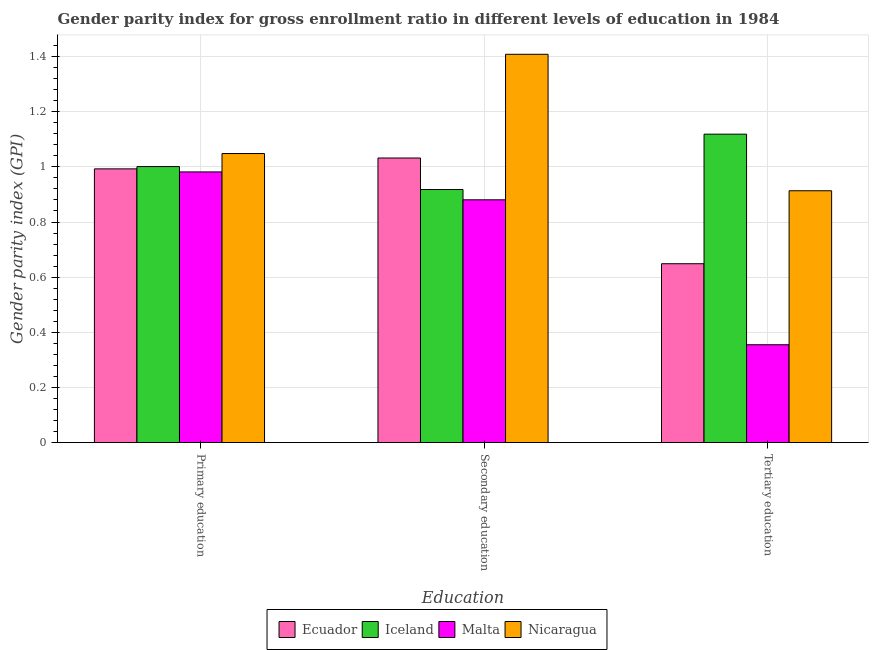How many different coloured bars are there?
Offer a very short reply. 4. How many groups of bars are there?
Your answer should be very brief. 3. What is the label of the 3rd group of bars from the left?
Your answer should be compact. Tertiary education. What is the gender parity index in primary education in Ecuador?
Offer a very short reply. 0.99. Across all countries, what is the maximum gender parity index in primary education?
Make the answer very short. 1.05. Across all countries, what is the minimum gender parity index in tertiary education?
Make the answer very short. 0.35. In which country was the gender parity index in secondary education maximum?
Provide a short and direct response. Nicaragua. In which country was the gender parity index in primary education minimum?
Your answer should be compact. Malta. What is the total gender parity index in secondary education in the graph?
Provide a succinct answer. 4.24. What is the difference between the gender parity index in primary education in Iceland and that in Nicaragua?
Your answer should be compact. -0.05. What is the difference between the gender parity index in secondary education in Ecuador and the gender parity index in tertiary education in Nicaragua?
Provide a succinct answer. 0.12. What is the average gender parity index in tertiary education per country?
Your answer should be compact. 0.76. What is the difference between the gender parity index in secondary education and gender parity index in tertiary education in Ecuador?
Your answer should be very brief. 0.38. In how many countries, is the gender parity index in secondary education greater than 0.7200000000000001 ?
Offer a very short reply. 4. What is the ratio of the gender parity index in tertiary education in Ecuador to that in Malta?
Offer a terse response. 1.83. Is the difference between the gender parity index in secondary education in Iceland and Nicaragua greater than the difference between the gender parity index in tertiary education in Iceland and Nicaragua?
Offer a terse response. No. What is the difference between the highest and the second highest gender parity index in primary education?
Provide a succinct answer. 0.05. What is the difference between the highest and the lowest gender parity index in secondary education?
Your response must be concise. 0.53. In how many countries, is the gender parity index in primary education greater than the average gender parity index in primary education taken over all countries?
Ensure brevity in your answer.  1. Is the sum of the gender parity index in primary education in Iceland and Nicaragua greater than the maximum gender parity index in tertiary education across all countries?
Provide a succinct answer. Yes. What does the 2nd bar from the left in Tertiary education represents?
Make the answer very short. Iceland. What does the 1st bar from the right in Primary education represents?
Ensure brevity in your answer.  Nicaragua. What is the difference between two consecutive major ticks on the Y-axis?
Provide a succinct answer. 0.2. Does the graph contain grids?
Your response must be concise. Yes. Where does the legend appear in the graph?
Your answer should be very brief. Bottom center. How are the legend labels stacked?
Keep it short and to the point. Horizontal. What is the title of the graph?
Make the answer very short. Gender parity index for gross enrollment ratio in different levels of education in 1984. What is the label or title of the X-axis?
Give a very brief answer. Education. What is the label or title of the Y-axis?
Offer a very short reply. Gender parity index (GPI). What is the Gender parity index (GPI) of Ecuador in Primary education?
Ensure brevity in your answer.  0.99. What is the Gender parity index (GPI) in Iceland in Primary education?
Offer a very short reply. 1. What is the Gender parity index (GPI) of Malta in Primary education?
Provide a short and direct response. 0.98. What is the Gender parity index (GPI) in Nicaragua in Primary education?
Your answer should be very brief. 1.05. What is the Gender parity index (GPI) in Ecuador in Secondary education?
Provide a succinct answer. 1.03. What is the Gender parity index (GPI) in Iceland in Secondary education?
Make the answer very short. 0.92. What is the Gender parity index (GPI) in Malta in Secondary education?
Your response must be concise. 0.88. What is the Gender parity index (GPI) of Nicaragua in Secondary education?
Your response must be concise. 1.41. What is the Gender parity index (GPI) in Ecuador in Tertiary education?
Offer a very short reply. 0.65. What is the Gender parity index (GPI) in Iceland in Tertiary education?
Your answer should be very brief. 1.12. What is the Gender parity index (GPI) of Malta in Tertiary education?
Your answer should be very brief. 0.35. What is the Gender parity index (GPI) of Nicaragua in Tertiary education?
Your response must be concise. 0.91. Across all Education, what is the maximum Gender parity index (GPI) of Ecuador?
Your response must be concise. 1.03. Across all Education, what is the maximum Gender parity index (GPI) of Iceland?
Offer a very short reply. 1.12. Across all Education, what is the maximum Gender parity index (GPI) of Malta?
Provide a succinct answer. 0.98. Across all Education, what is the maximum Gender parity index (GPI) of Nicaragua?
Offer a very short reply. 1.41. Across all Education, what is the minimum Gender parity index (GPI) of Ecuador?
Keep it short and to the point. 0.65. Across all Education, what is the minimum Gender parity index (GPI) of Iceland?
Offer a terse response. 0.92. Across all Education, what is the minimum Gender parity index (GPI) in Malta?
Your response must be concise. 0.35. Across all Education, what is the minimum Gender parity index (GPI) in Nicaragua?
Provide a short and direct response. 0.91. What is the total Gender parity index (GPI) in Ecuador in the graph?
Ensure brevity in your answer.  2.67. What is the total Gender parity index (GPI) in Iceland in the graph?
Keep it short and to the point. 3.04. What is the total Gender parity index (GPI) of Malta in the graph?
Keep it short and to the point. 2.22. What is the total Gender parity index (GPI) of Nicaragua in the graph?
Offer a very short reply. 3.37. What is the difference between the Gender parity index (GPI) in Ecuador in Primary education and that in Secondary education?
Provide a short and direct response. -0.04. What is the difference between the Gender parity index (GPI) in Iceland in Primary education and that in Secondary education?
Your answer should be very brief. 0.08. What is the difference between the Gender parity index (GPI) of Malta in Primary education and that in Secondary education?
Your answer should be very brief. 0.1. What is the difference between the Gender parity index (GPI) in Nicaragua in Primary education and that in Secondary education?
Your answer should be compact. -0.36. What is the difference between the Gender parity index (GPI) of Ecuador in Primary education and that in Tertiary education?
Make the answer very short. 0.34. What is the difference between the Gender parity index (GPI) in Iceland in Primary education and that in Tertiary education?
Keep it short and to the point. -0.12. What is the difference between the Gender parity index (GPI) in Malta in Primary education and that in Tertiary education?
Your answer should be compact. 0.63. What is the difference between the Gender parity index (GPI) in Nicaragua in Primary education and that in Tertiary education?
Offer a very short reply. 0.14. What is the difference between the Gender parity index (GPI) of Ecuador in Secondary education and that in Tertiary education?
Your answer should be very brief. 0.38. What is the difference between the Gender parity index (GPI) of Iceland in Secondary education and that in Tertiary education?
Offer a terse response. -0.2. What is the difference between the Gender parity index (GPI) in Malta in Secondary education and that in Tertiary education?
Offer a terse response. 0.53. What is the difference between the Gender parity index (GPI) in Nicaragua in Secondary education and that in Tertiary education?
Your answer should be very brief. 0.49. What is the difference between the Gender parity index (GPI) of Ecuador in Primary education and the Gender parity index (GPI) of Iceland in Secondary education?
Your answer should be very brief. 0.07. What is the difference between the Gender parity index (GPI) in Ecuador in Primary education and the Gender parity index (GPI) in Malta in Secondary education?
Your answer should be very brief. 0.11. What is the difference between the Gender parity index (GPI) in Ecuador in Primary education and the Gender parity index (GPI) in Nicaragua in Secondary education?
Provide a short and direct response. -0.42. What is the difference between the Gender parity index (GPI) in Iceland in Primary education and the Gender parity index (GPI) in Malta in Secondary education?
Ensure brevity in your answer.  0.12. What is the difference between the Gender parity index (GPI) in Iceland in Primary education and the Gender parity index (GPI) in Nicaragua in Secondary education?
Ensure brevity in your answer.  -0.41. What is the difference between the Gender parity index (GPI) in Malta in Primary education and the Gender parity index (GPI) in Nicaragua in Secondary education?
Provide a succinct answer. -0.43. What is the difference between the Gender parity index (GPI) in Ecuador in Primary education and the Gender parity index (GPI) in Iceland in Tertiary education?
Provide a short and direct response. -0.13. What is the difference between the Gender parity index (GPI) in Ecuador in Primary education and the Gender parity index (GPI) in Malta in Tertiary education?
Provide a short and direct response. 0.64. What is the difference between the Gender parity index (GPI) of Ecuador in Primary education and the Gender parity index (GPI) of Nicaragua in Tertiary education?
Keep it short and to the point. 0.08. What is the difference between the Gender parity index (GPI) in Iceland in Primary education and the Gender parity index (GPI) in Malta in Tertiary education?
Your response must be concise. 0.65. What is the difference between the Gender parity index (GPI) of Iceland in Primary education and the Gender parity index (GPI) of Nicaragua in Tertiary education?
Ensure brevity in your answer.  0.09. What is the difference between the Gender parity index (GPI) in Malta in Primary education and the Gender parity index (GPI) in Nicaragua in Tertiary education?
Ensure brevity in your answer.  0.07. What is the difference between the Gender parity index (GPI) of Ecuador in Secondary education and the Gender parity index (GPI) of Iceland in Tertiary education?
Ensure brevity in your answer.  -0.09. What is the difference between the Gender parity index (GPI) in Ecuador in Secondary education and the Gender parity index (GPI) in Malta in Tertiary education?
Ensure brevity in your answer.  0.68. What is the difference between the Gender parity index (GPI) in Ecuador in Secondary education and the Gender parity index (GPI) in Nicaragua in Tertiary education?
Offer a terse response. 0.12. What is the difference between the Gender parity index (GPI) of Iceland in Secondary education and the Gender parity index (GPI) of Malta in Tertiary education?
Your answer should be very brief. 0.56. What is the difference between the Gender parity index (GPI) in Iceland in Secondary education and the Gender parity index (GPI) in Nicaragua in Tertiary education?
Give a very brief answer. 0. What is the difference between the Gender parity index (GPI) of Malta in Secondary education and the Gender parity index (GPI) of Nicaragua in Tertiary education?
Keep it short and to the point. -0.03. What is the average Gender parity index (GPI) in Ecuador per Education?
Your answer should be very brief. 0.89. What is the average Gender parity index (GPI) of Iceland per Education?
Your response must be concise. 1.01. What is the average Gender parity index (GPI) in Malta per Education?
Offer a very short reply. 0.74. What is the average Gender parity index (GPI) of Nicaragua per Education?
Your answer should be very brief. 1.12. What is the difference between the Gender parity index (GPI) in Ecuador and Gender parity index (GPI) in Iceland in Primary education?
Ensure brevity in your answer.  -0.01. What is the difference between the Gender parity index (GPI) of Ecuador and Gender parity index (GPI) of Malta in Primary education?
Keep it short and to the point. 0.01. What is the difference between the Gender parity index (GPI) of Ecuador and Gender parity index (GPI) of Nicaragua in Primary education?
Your answer should be compact. -0.06. What is the difference between the Gender parity index (GPI) of Iceland and Gender parity index (GPI) of Malta in Primary education?
Provide a succinct answer. 0.02. What is the difference between the Gender parity index (GPI) of Iceland and Gender parity index (GPI) of Nicaragua in Primary education?
Your response must be concise. -0.05. What is the difference between the Gender parity index (GPI) of Malta and Gender parity index (GPI) of Nicaragua in Primary education?
Keep it short and to the point. -0.07. What is the difference between the Gender parity index (GPI) in Ecuador and Gender parity index (GPI) in Iceland in Secondary education?
Provide a succinct answer. 0.11. What is the difference between the Gender parity index (GPI) in Ecuador and Gender parity index (GPI) in Malta in Secondary education?
Your answer should be compact. 0.15. What is the difference between the Gender parity index (GPI) of Ecuador and Gender parity index (GPI) of Nicaragua in Secondary education?
Make the answer very short. -0.38. What is the difference between the Gender parity index (GPI) of Iceland and Gender parity index (GPI) of Malta in Secondary education?
Offer a terse response. 0.04. What is the difference between the Gender parity index (GPI) of Iceland and Gender parity index (GPI) of Nicaragua in Secondary education?
Your answer should be compact. -0.49. What is the difference between the Gender parity index (GPI) of Malta and Gender parity index (GPI) of Nicaragua in Secondary education?
Your answer should be very brief. -0.53. What is the difference between the Gender parity index (GPI) of Ecuador and Gender parity index (GPI) of Iceland in Tertiary education?
Keep it short and to the point. -0.47. What is the difference between the Gender parity index (GPI) in Ecuador and Gender parity index (GPI) in Malta in Tertiary education?
Make the answer very short. 0.29. What is the difference between the Gender parity index (GPI) in Ecuador and Gender parity index (GPI) in Nicaragua in Tertiary education?
Ensure brevity in your answer.  -0.26. What is the difference between the Gender parity index (GPI) of Iceland and Gender parity index (GPI) of Malta in Tertiary education?
Provide a succinct answer. 0.76. What is the difference between the Gender parity index (GPI) of Iceland and Gender parity index (GPI) of Nicaragua in Tertiary education?
Your response must be concise. 0.21. What is the difference between the Gender parity index (GPI) in Malta and Gender parity index (GPI) in Nicaragua in Tertiary education?
Your answer should be compact. -0.56. What is the ratio of the Gender parity index (GPI) of Ecuador in Primary education to that in Secondary education?
Offer a very short reply. 0.96. What is the ratio of the Gender parity index (GPI) in Iceland in Primary education to that in Secondary education?
Provide a short and direct response. 1.09. What is the ratio of the Gender parity index (GPI) in Malta in Primary education to that in Secondary education?
Your answer should be compact. 1.11. What is the ratio of the Gender parity index (GPI) of Nicaragua in Primary education to that in Secondary education?
Your answer should be compact. 0.74. What is the ratio of the Gender parity index (GPI) of Ecuador in Primary education to that in Tertiary education?
Offer a very short reply. 1.53. What is the ratio of the Gender parity index (GPI) of Iceland in Primary education to that in Tertiary education?
Provide a succinct answer. 0.89. What is the ratio of the Gender parity index (GPI) of Malta in Primary education to that in Tertiary education?
Offer a terse response. 2.77. What is the ratio of the Gender parity index (GPI) in Nicaragua in Primary education to that in Tertiary education?
Your answer should be very brief. 1.15. What is the ratio of the Gender parity index (GPI) of Ecuador in Secondary education to that in Tertiary education?
Give a very brief answer. 1.59. What is the ratio of the Gender parity index (GPI) of Iceland in Secondary education to that in Tertiary education?
Make the answer very short. 0.82. What is the ratio of the Gender parity index (GPI) in Malta in Secondary education to that in Tertiary education?
Give a very brief answer. 2.48. What is the ratio of the Gender parity index (GPI) of Nicaragua in Secondary education to that in Tertiary education?
Ensure brevity in your answer.  1.54. What is the difference between the highest and the second highest Gender parity index (GPI) of Ecuador?
Ensure brevity in your answer.  0.04. What is the difference between the highest and the second highest Gender parity index (GPI) in Iceland?
Offer a very short reply. 0.12. What is the difference between the highest and the second highest Gender parity index (GPI) of Malta?
Ensure brevity in your answer.  0.1. What is the difference between the highest and the second highest Gender parity index (GPI) of Nicaragua?
Provide a succinct answer. 0.36. What is the difference between the highest and the lowest Gender parity index (GPI) of Ecuador?
Provide a succinct answer. 0.38. What is the difference between the highest and the lowest Gender parity index (GPI) of Iceland?
Make the answer very short. 0.2. What is the difference between the highest and the lowest Gender parity index (GPI) of Malta?
Your answer should be very brief. 0.63. What is the difference between the highest and the lowest Gender parity index (GPI) of Nicaragua?
Your response must be concise. 0.49. 